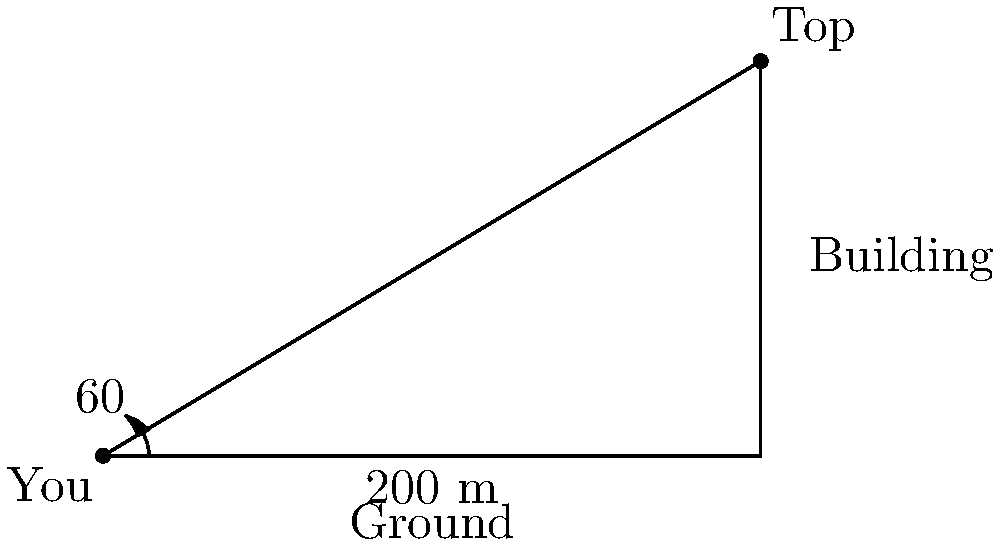You're standing at the base of the "Giggle Tower," rumored to be the world's tallest and funniest skyscraper. Your neck is craning at a $60°$ angle just to see the top, and you're exactly 200 meters away from its base. How tall is this comically large structure? Round your answer to the nearest meter. Let's tackle this step by step, with a smile on our face:

1) First, we need to identify the trigonometric function that relates the angle of elevation and the distance to the height of the building. In this case, it's tangent.

2) The tangent of an angle in a right triangle is the ratio of the opposite side (building height) to the adjacent side (distance from the base).

3) Let's set up our equation:
   $\tan(60°) = \frac{\text{height}}{\text{distance}}$

4) We know the distance is 200 meters, so let's plug that in:
   $\tan(60°) = \frac{\text{height}}{200}$

5) Now, let's solve for height:
   $\text{height} = 200 \tan(60°)$

6) We know that $\tan(60°) = \sqrt{3}$, so:
   $\text{height} = 200 \sqrt{3}$

7) Let's calculate this:
   $\text{height} = 200 * 1.732050808 \approx 346.4$ meters

8) Rounding to the nearest meter:
   $\text{height} \approx 346$ meters
Answer: 346 meters 